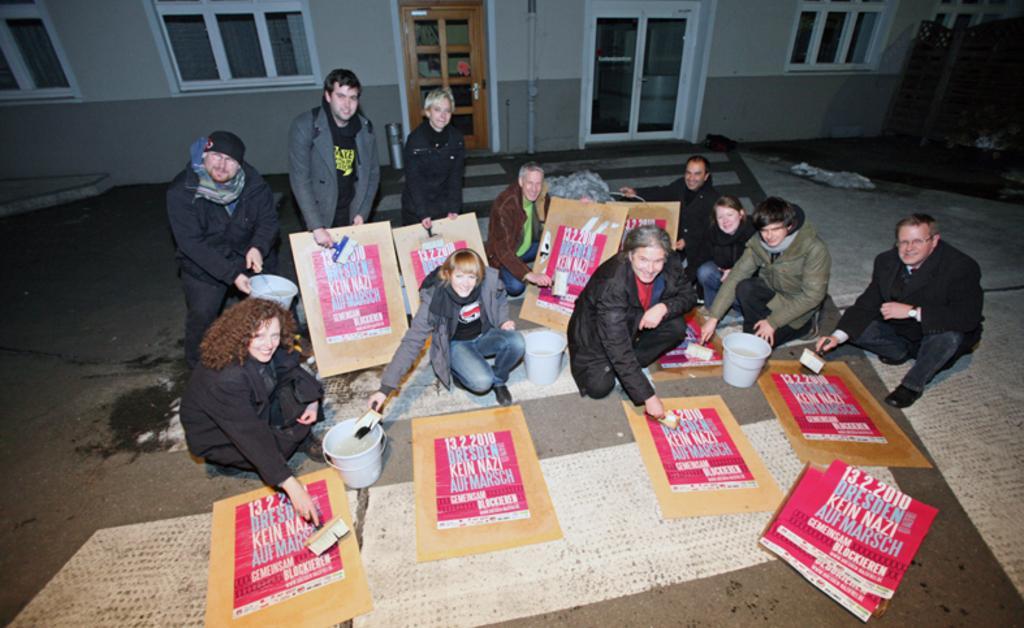How would you summarize this image in a sentence or two? In the center of the picture there are people, posters, buckets, brushes and other objects. In the background there is a building, to the building there are windows and doors. On the right there are some wooden objects. 